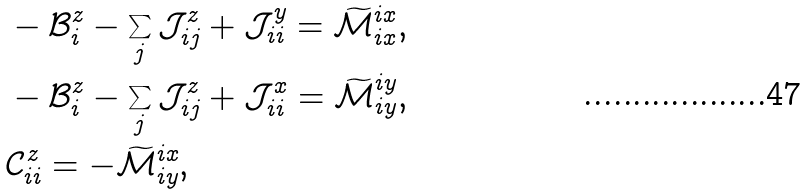Convert formula to latex. <formula><loc_0><loc_0><loc_500><loc_500>& - \mathcal { B } _ { i } ^ { z } - \sum _ { j } \mathcal { J } _ { i j } ^ { z } + \mathcal { J } _ { i i } ^ { y } = \widetilde { \mathcal { M } } ^ { i x } _ { i x } , \\ & - \mathcal { B } _ { i } ^ { z } - \sum _ { j } \mathcal { J } _ { i j } ^ { z } + \mathcal { J } _ { i i } ^ { x } = \widetilde { \mathcal { M } } ^ { i y } _ { i y } , \\ & \mathcal { C } _ { i i } ^ { z } = - \widetilde { \mathcal { M } } ^ { i x } _ { i y } ,</formula> 